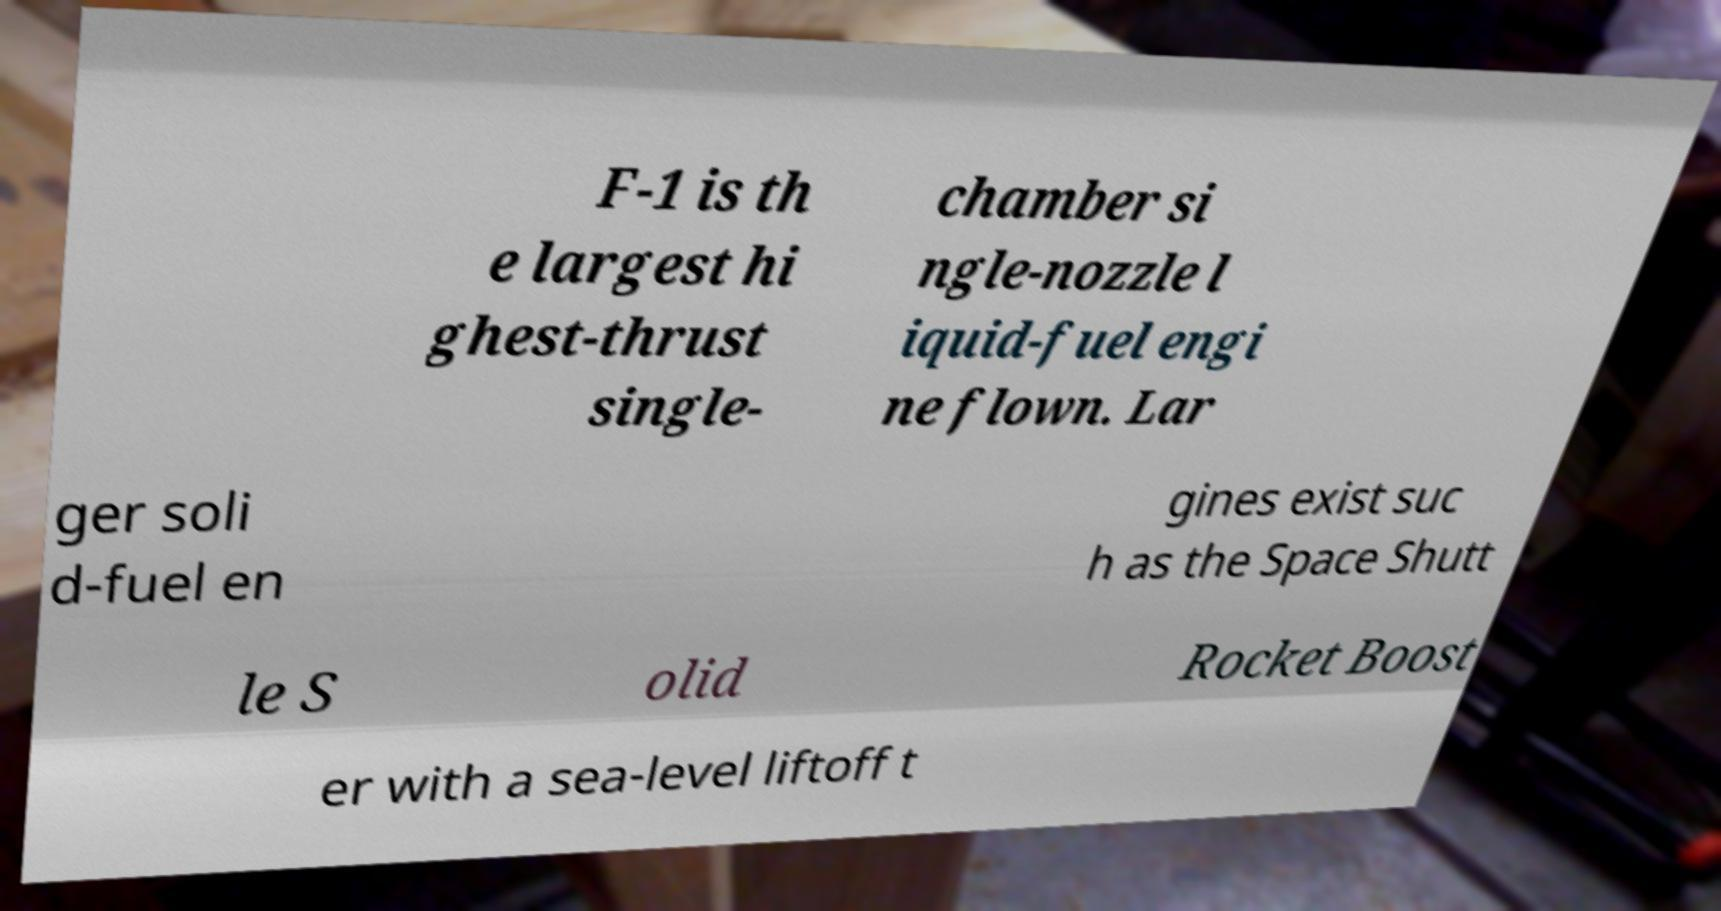Could you assist in decoding the text presented in this image and type it out clearly? F-1 is th e largest hi ghest-thrust single- chamber si ngle-nozzle l iquid-fuel engi ne flown. Lar ger soli d-fuel en gines exist suc h as the Space Shutt le S olid Rocket Boost er with a sea-level liftoff t 